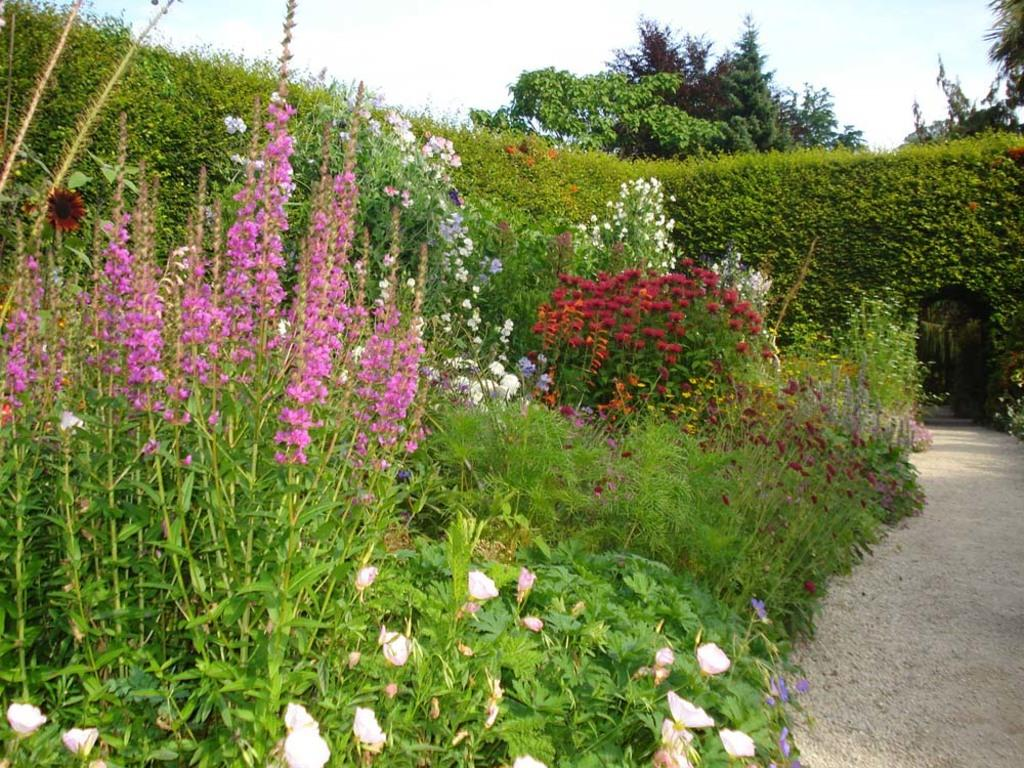What can be seen in the image that people might walk on? There is a path in the image that people might walk on. What structure is visible in the image? There is an arch in the image. What type of plants are present in the image? There are plants with flowers in the image. What can be seen in the background of the image? There are trees and the sky visible in the background of the image. What type of beef is being served to the friend in the image? There is no beef or friend present in the image; it features a path, an arch, plants with flowers, trees, and the sky. How can you help the person in the image who needs assistance? There is no person in the image who needs help; it is a landscape image with a path, an arch, plants with flowers, trees, and the sky. 